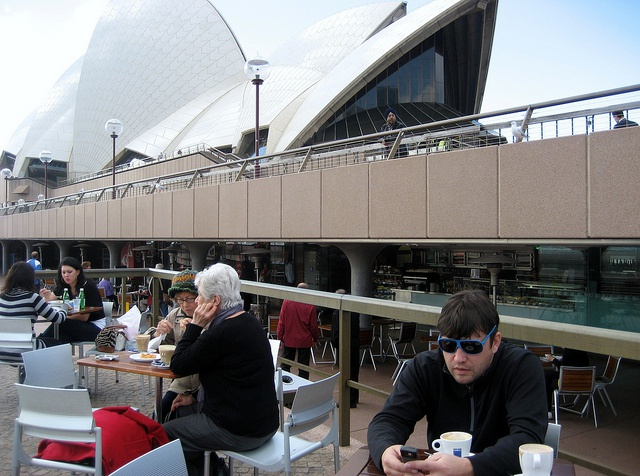Describe the objects in this image and their specific colors. I can see people in white, black, and gray tones, people in white, black, darkgray, gray, and lightgray tones, chair in white, darkgray, lightblue, gray, and maroon tones, chair in white, gray, darkgray, and black tones, and backpack in white, maroon, brown, and black tones in this image. 